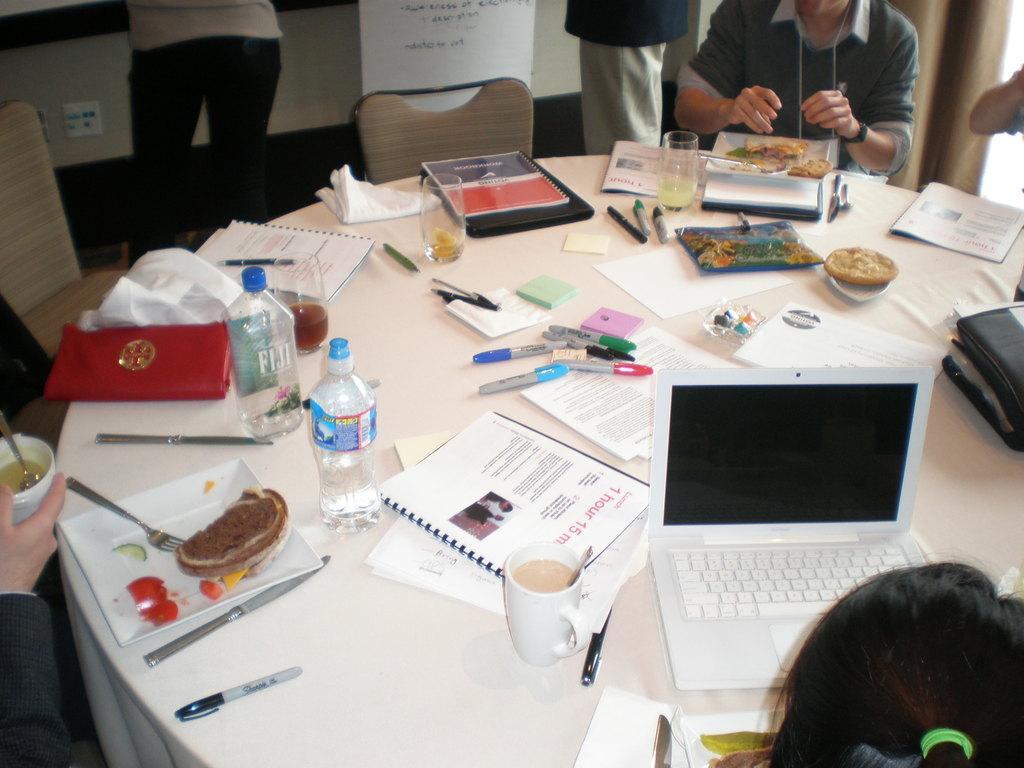Please provide a concise description of this image. Some persons are sitting on a chairs. Some persons are standing. There is a table. There is a laptop,plate ,pen,bottle,glass,paper,book on a table. 